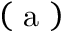Convert formula to latex. <formula><loc_0><loc_0><loc_500><loc_500>\left ( a \right )</formula> 